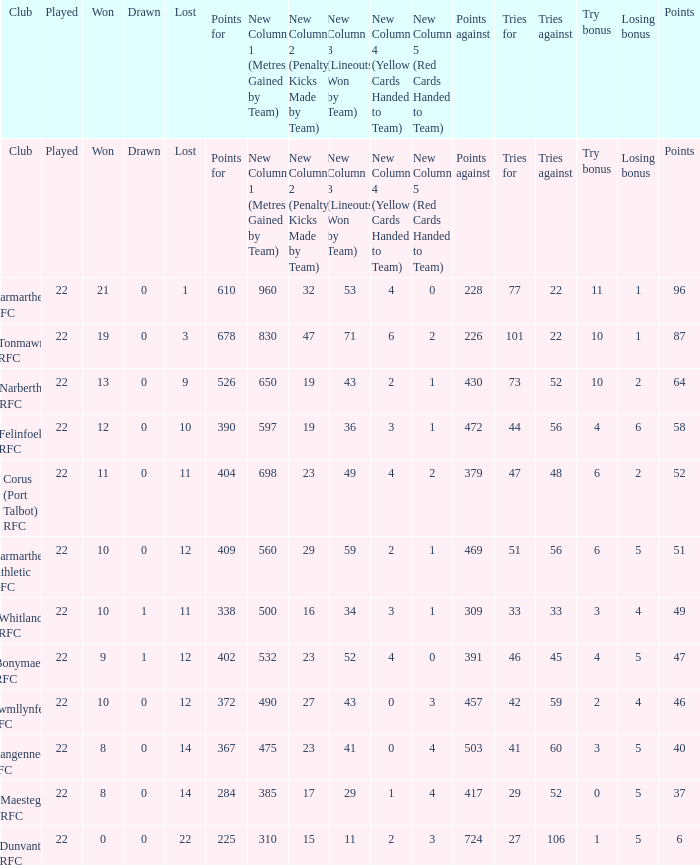Name the losing bonus of 96 points 1.0. 